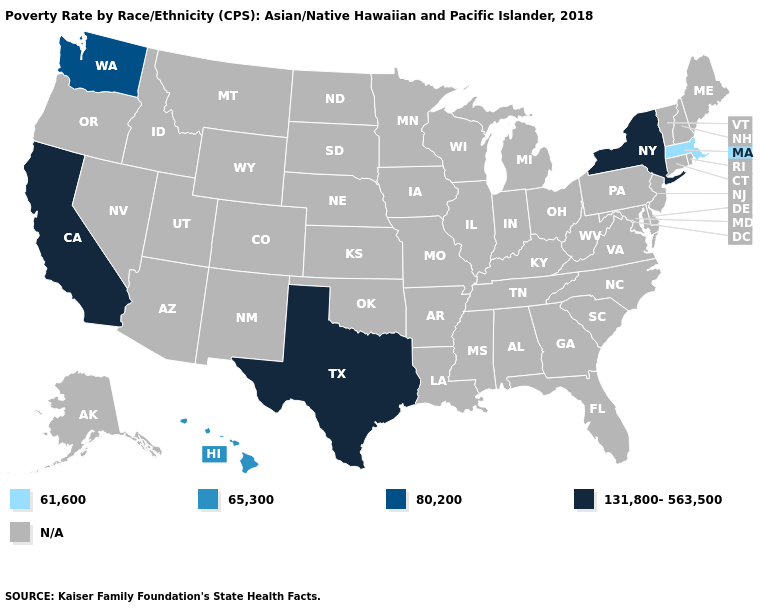Does the first symbol in the legend represent the smallest category?
Keep it brief. Yes. Name the states that have a value in the range N/A?
Concise answer only. Alabama, Alaska, Arizona, Arkansas, Colorado, Connecticut, Delaware, Florida, Georgia, Idaho, Illinois, Indiana, Iowa, Kansas, Kentucky, Louisiana, Maine, Maryland, Michigan, Minnesota, Mississippi, Missouri, Montana, Nebraska, Nevada, New Hampshire, New Jersey, New Mexico, North Carolina, North Dakota, Ohio, Oklahoma, Oregon, Pennsylvania, Rhode Island, South Carolina, South Dakota, Tennessee, Utah, Vermont, Virginia, West Virginia, Wisconsin, Wyoming. Name the states that have a value in the range N/A?
Short answer required. Alabama, Alaska, Arizona, Arkansas, Colorado, Connecticut, Delaware, Florida, Georgia, Idaho, Illinois, Indiana, Iowa, Kansas, Kentucky, Louisiana, Maine, Maryland, Michigan, Minnesota, Mississippi, Missouri, Montana, Nebraska, Nevada, New Hampshire, New Jersey, New Mexico, North Carolina, North Dakota, Ohio, Oklahoma, Oregon, Pennsylvania, Rhode Island, South Carolina, South Dakota, Tennessee, Utah, Vermont, Virginia, West Virginia, Wisconsin, Wyoming. Name the states that have a value in the range 61,600?
Keep it brief. Massachusetts. Does Hawaii have the lowest value in the West?
Answer briefly. Yes. Name the states that have a value in the range 65,300?
Answer briefly. Hawaii. What is the value of Wyoming?
Give a very brief answer. N/A. Name the states that have a value in the range 65,300?
Keep it brief. Hawaii. Name the states that have a value in the range 131,800-563,500?
Give a very brief answer. California, New York, Texas. What is the value of Oregon?
Quick response, please. N/A. How many symbols are there in the legend?
Keep it brief. 5. Name the states that have a value in the range 80,200?
Keep it brief. Washington. 